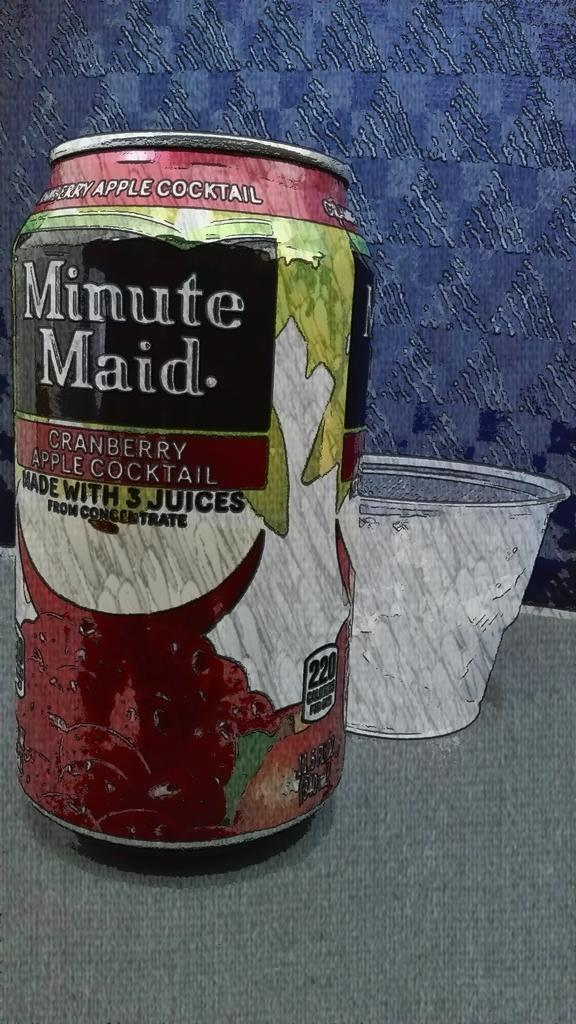<image>
Describe the image concisely. A can of Minute Maid Cranberry Apple Cocktail juice. 